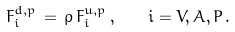<formula> <loc_0><loc_0><loc_500><loc_500>F ^ { d , p } _ { i } \, = \, \rho \, F ^ { u , p } _ { i } \, , \quad i = V , A , P \, .</formula> 